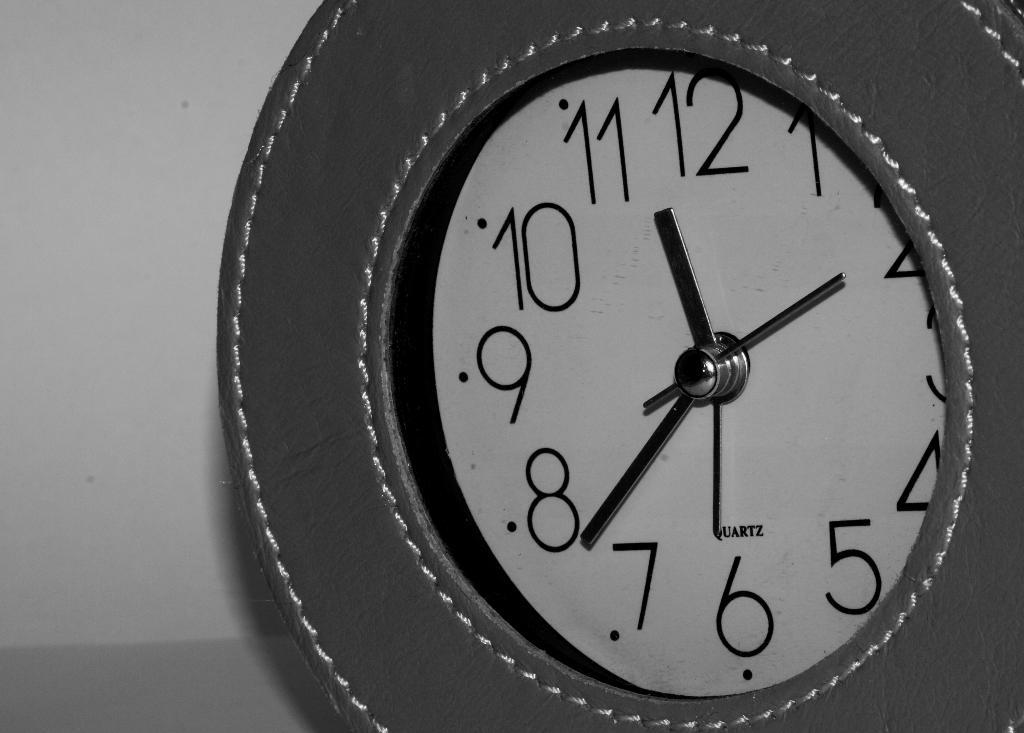Provide a one-sentence caption for the provided image. The Quartz wall clock has a nice look to it. 